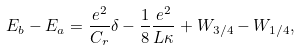Convert formula to latex. <formula><loc_0><loc_0><loc_500><loc_500>E _ { b } - E _ { a } = \frac { e ^ { 2 } } { C _ { r } } \delta - \frac { 1 } { 8 } \frac { e ^ { 2 } } { L \kappa } + W _ { 3 / 4 } - W _ { 1 / 4 } ,</formula> 